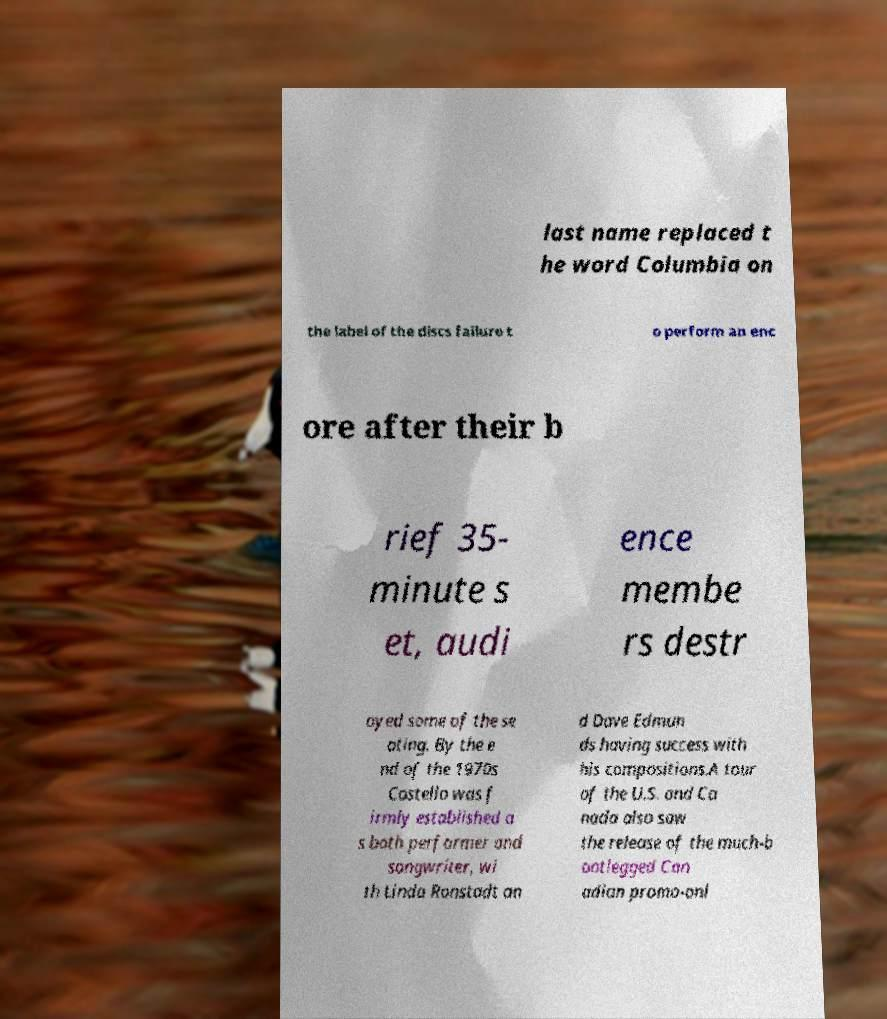I need the written content from this picture converted into text. Can you do that? last name replaced t he word Columbia on the label of the discs failure t o perform an enc ore after their b rief 35- minute s et, audi ence membe rs destr oyed some of the se ating. By the e nd of the 1970s Costello was f irmly established a s both performer and songwriter, wi th Linda Ronstadt an d Dave Edmun ds having success with his compositions.A tour of the U.S. and Ca nada also saw the release of the much-b ootlegged Can adian promo-onl 